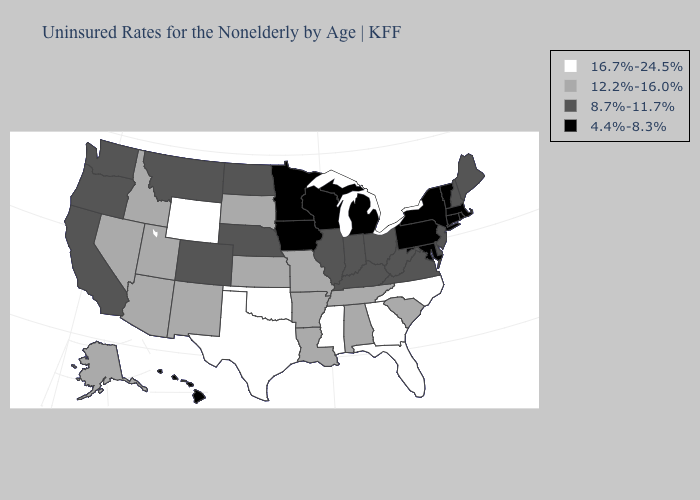What is the value of South Carolina?
Short answer required. 12.2%-16.0%. Does New York have the lowest value in the USA?
Answer briefly. Yes. What is the highest value in states that border Virginia?
Give a very brief answer. 16.7%-24.5%. What is the lowest value in the Northeast?
Be succinct. 4.4%-8.3%. What is the highest value in the USA?
Concise answer only. 16.7%-24.5%. What is the value of Wisconsin?
Short answer required. 4.4%-8.3%. Name the states that have a value in the range 4.4%-8.3%?
Keep it brief. Connecticut, Hawaii, Iowa, Maryland, Massachusetts, Michigan, Minnesota, New York, Pennsylvania, Rhode Island, Vermont, Wisconsin. Which states hav the highest value in the Northeast?
Concise answer only. Maine, New Hampshire, New Jersey. Name the states that have a value in the range 8.7%-11.7%?
Be succinct. California, Colorado, Delaware, Illinois, Indiana, Kentucky, Maine, Montana, Nebraska, New Hampshire, New Jersey, North Dakota, Ohio, Oregon, Virginia, Washington, West Virginia. What is the value of Pennsylvania?
Write a very short answer. 4.4%-8.3%. Does North Dakota have the lowest value in the USA?
Give a very brief answer. No. What is the lowest value in states that border Washington?
Answer briefly. 8.7%-11.7%. Does Alabama have the highest value in the USA?
Be succinct. No. What is the value of Montana?
Answer briefly. 8.7%-11.7%. Among the states that border Idaho , does Oregon have the lowest value?
Short answer required. Yes. 